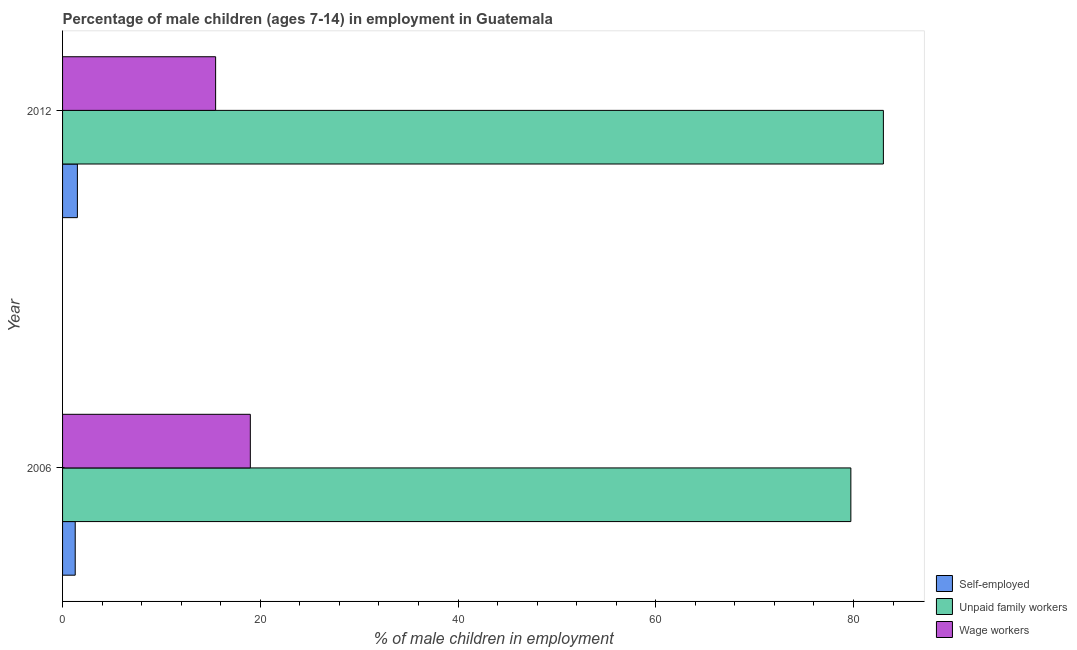How many groups of bars are there?
Your response must be concise. 2. How many bars are there on the 1st tick from the bottom?
Offer a very short reply. 3. What is the label of the 1st group of bars from the top?
Make the answer very short. 2012. What is the percentage of self employed children in 2006?
Keep it short and to the point. 1.28. Across all years, what is the maximum percentage of children employed as wage workers?
Give a very brief answer. 18.99. Across all years, what is the minimum percentage of self employed children?
Provide a succinct answer. 1.28. In which year was the percentage of self employed children maximum?
Your answer should be very brief. 2012. What is the total percentage of children employed as unpaid family workers in the graph?
Give a very brief answer. 162.75. What is the difference between the percentage of children employed as unpaid family workers in 2006 and that in 2012?
Give a very brief answer. -3.29. What is the difference between the percentage of children employed as wage workers in 2006 and the percentage of self employed children in 2012?
Ensure brevity in your answer.  17.49. What is the average percentage of children employed as unpaid family workers per year?
Provide a succinct answer. 81.38. In the year 2012, what is the difference between the percentage of children employed as unpaid family workers and percentage of children employed as wage workers?
Your answer should be compact. 67.54. In how many years, is the percentage of self employed children greater than 60 %?
Keep it short and to the point. 0. What is the ratio of the percentage of children employed as unpaid family workers in 2006 to that in 2012?
Your answer should be very brief. 0.96. Is the percentage of children employed as wage workers in 2006 less than that in 2012?
Offer a terse response. No. In how many years, is the percentage of self employed children greater than the average percentage of self employed children taken over all years?
Ensure brevity in your answer.  1. What does the 2nd bar from the top in 2012 represents?
Your answer should be compact. Unpaid family workers. What does the 1st bar from the bottom in 2006 represents?
Ensure brevity in your answer.  Self-employed. Is it the case that in every year, the sum of the percentage of self employed children and percentage of children employed as unpaid family workers is greater than the percentage of children employed as wage workers?
Give a very brief answer. Yes. How many bars are there?
Make the answer very short. 6. How many years are there in the graph?
Ensure brevity in your answer.  2. What is the difference between two consecutive major ticks on the X-axis?
Ensure brevity in your answer.  20. Are the values on the major ticks of X-axis written in scientific E-notation?
Keep it short and to the point. No. Does the graph contain grids?
Your response must be concise. No. Where does the legend appear in the graph?
Provide a succinct answer. Bottom right. How many legend labels are there?
Keep it short and to the point. 3. How are the legend labels stacked?
Keep it short and to the point. Vertical. What is the title of the graph?
Ensure brevity in your answer.  Percentage of male children (ages 7-14) in employment in Guatemala. Does "Fuel" appear as one of the legend labels in the graph?
Make the answer very short. No. What is the label or title of the X-axis?
Make the answer very short. % of male children in employment. What is the % of male children in employment in Self-employed in 2006?
Offer a terse response. 1.28. What is the % of male children in employment of Unpaid family workers in 2006?
Ensure brevity in your answer.  79.73. What is the % of male children in employment of Wage workers in 2006?
Give a very brief answer. 18.99. What is the % of male children in employment of Self-employed in 2012?
Offer a terse response. 1.5. What is the % of male children in employment of Unpaid family workers in 2012?
Your answer should be compact. 83.02. What is the % of male children in employment of Wage workers in 2012?
Offer a very short reply. 15.48. Across all years, what is the maximum % of male children in employment in Unpaid family workers?
Offer a very short reply. 83.02. Across all years, what is the maximum % of male children in employment in Wage workers?
Make the answer very short. 18.99. Across all years, what is the minimum % of male children in employment of Self-employed?
Your response must be concise. 1.28. Across all years, what is the minimum % of male children in employment of Unpaid family workers?
Offer a terse response. 79.73. Across all years, what is the minimum % of male children in employment of Wage workers?
Provide a short and direct response. 15.48. What is the total % of male children in employment of Self-employed in the graph?
Provide a short and direct response. 2.78. What is the total % of male children in employment in Unpaid family workers in the graph?
Your response must be concise. 162.75. What is the total % of male children in employment in Wage workers in the graph?
Offer a terse response. 34.47. What is the difference between the % of male children in employment in Self-employed in 2006 and that in 2012?
Give a very brief answer. -0.22. What is the difference between the % of male children in employment of Unpaid family workers in 2006 and that in 2012?
Offer a very short reply. -3.29. What is the difference between the % of male children in employment of Wage workers in 2006 and that in 2012?
Provide a succinct answer. 3.51. What is the difference between the % of male children in employment in Self-employed in 2006 and the % of male children in employment in Unpaid family workers in 2012?
Keep it short and to the point. -81.74. What is the difference between the % of male children in employment of Self-employed in 2006 and the % of male children in employment of Wage workers in 2012?
Offer a very short reply. -14.2. What is the difference between the % of male children in employment in Unpaid family workers in 2006 and the % of male children in employment in Wage workers in 2012?
Your response must be concise. 64.25. What is the average % of male children in employment in Self-employed per year?
Give a very brief answer. 1.39. What is the average % of male children in employment in Unpaid family workers per year?
Give a very brief answer. 81.38. What is the average % of male children in employment in Wage workers per year?
Make the answer very short. 17.23. In the year 2006, what is the difference between the % of male children in employment in Self-employed and % of male children in employment in Unpaid family workers?
Make the answer very short. -78.45. In the year 2006, what is the difference between the % of male children in employment in Self-employed and % of male children in employment in Wage workers?
Give a very brief answer. -17.71. In the year 2006, what is the difference between the % of male children in employment in Unpaid family workers and % of male children in employment in Wage workers?
Keep it short and to the point. 60.74. In the year 2012, what is the difference between the % of male children in employment of Self-employed and % of male children in employment of Unpaid family workers?
Your answer should be very brief. -81.52. In the year 2012, what is the difference between the % of male children in employment of Self-employed and % of male children in employment of Wage workers?
Keep it short and to the point. -13.98. In the year 2012, what is the difference between the % of male children in employment of Unpaid family workers and % of male children in employment of Wage workers?
Provide a succinct answer. 67.54. What is the ratio of the % of male children in employment of Self-employed in 2006 to that in 2012?
Your answer should be compact. 0.85. What is the ratio of the % of male children in employment in Unpaid family workers in 2006 to that in 2012?
Offer a terse response. 0.96. What is the ratio of the % of male children in employment of Wage workers in 2006 to that in 2012?
Give a very brief answer. 1.23. What is the difference between the highest and the second highest % of male children in employment in Self-employed?
Provide a short and direct response. 0.22. What is the difference between the highest and the second highest % of male children in employment in Unpaid family workers?
Provide a short and direct response. 3.29. What is the difference between the highest and the second highest % of male children in employment in Wage workers?
Give a very brief answer. 3.51. What is the difference between the highest and the lowest % of male children in employment in Self-employed?
Your answer should be very brief. 0.22. What is the difference between the highest and the lowest % of male children in employment in Unpaid family workers?
Your answer should be very brief. 3.29. What is the difference between the highest and the lowest % of male children in employment in Wage workers?
Give a very brief answer. 3.51. 